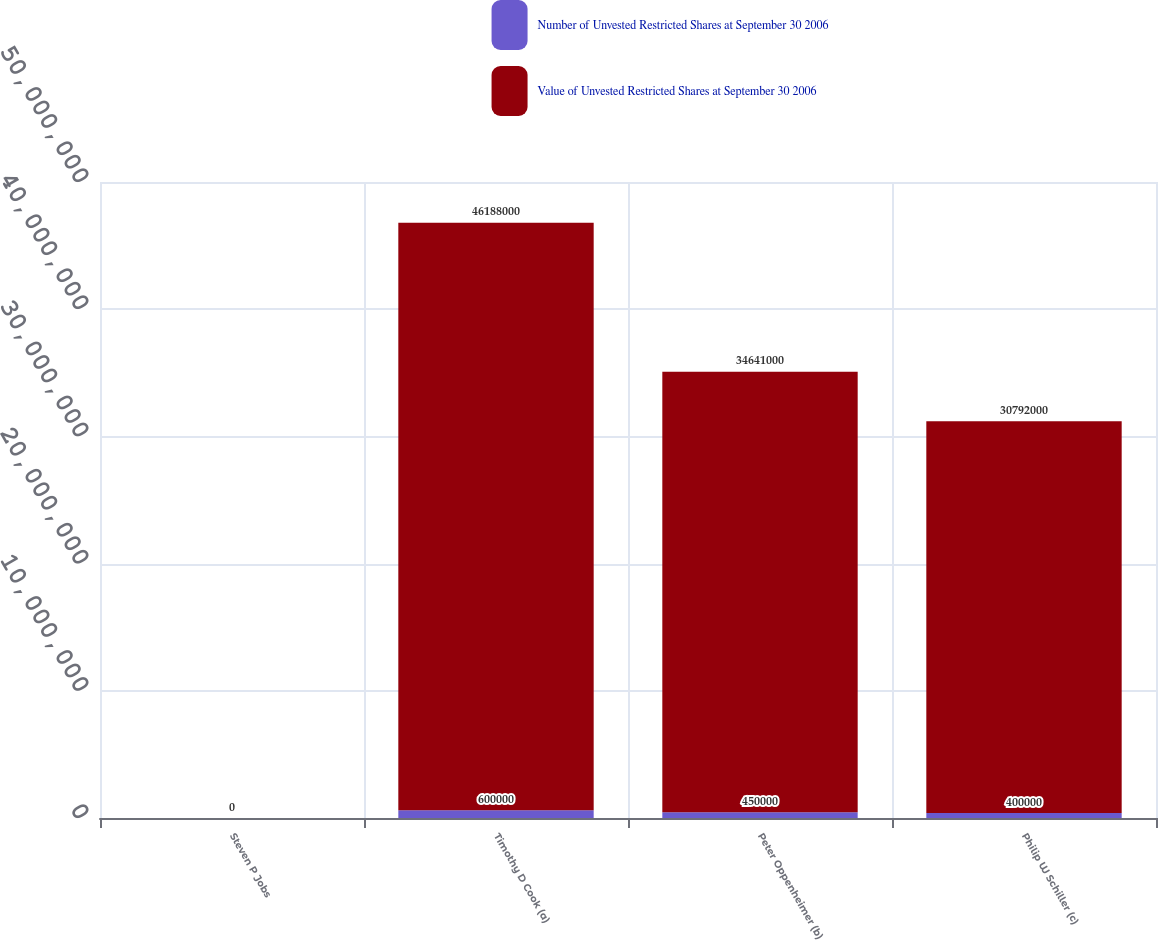<chart> <loc_0><loc_0><loc_500><loc_500><stacked_bar_chart><ecel><fcel>Steven P Jobs<fcel>Timothy D Cook (a)<fcel>Peter Oppenheimer (b)<fcel>Philip W Schiller (c)<nl><fcel>Number of Unvested Restricted Shares at September 30 2006<fcel>0<fcel>600000<fcel>450000<fcel>400000<nl><fcel>Value of Unvested Restricted Shares at September 30 2006<fcel>0<fcel>4.6188e+07<fcel>3.4641e+07<fcel>3.0792e+07<nl></chart> 